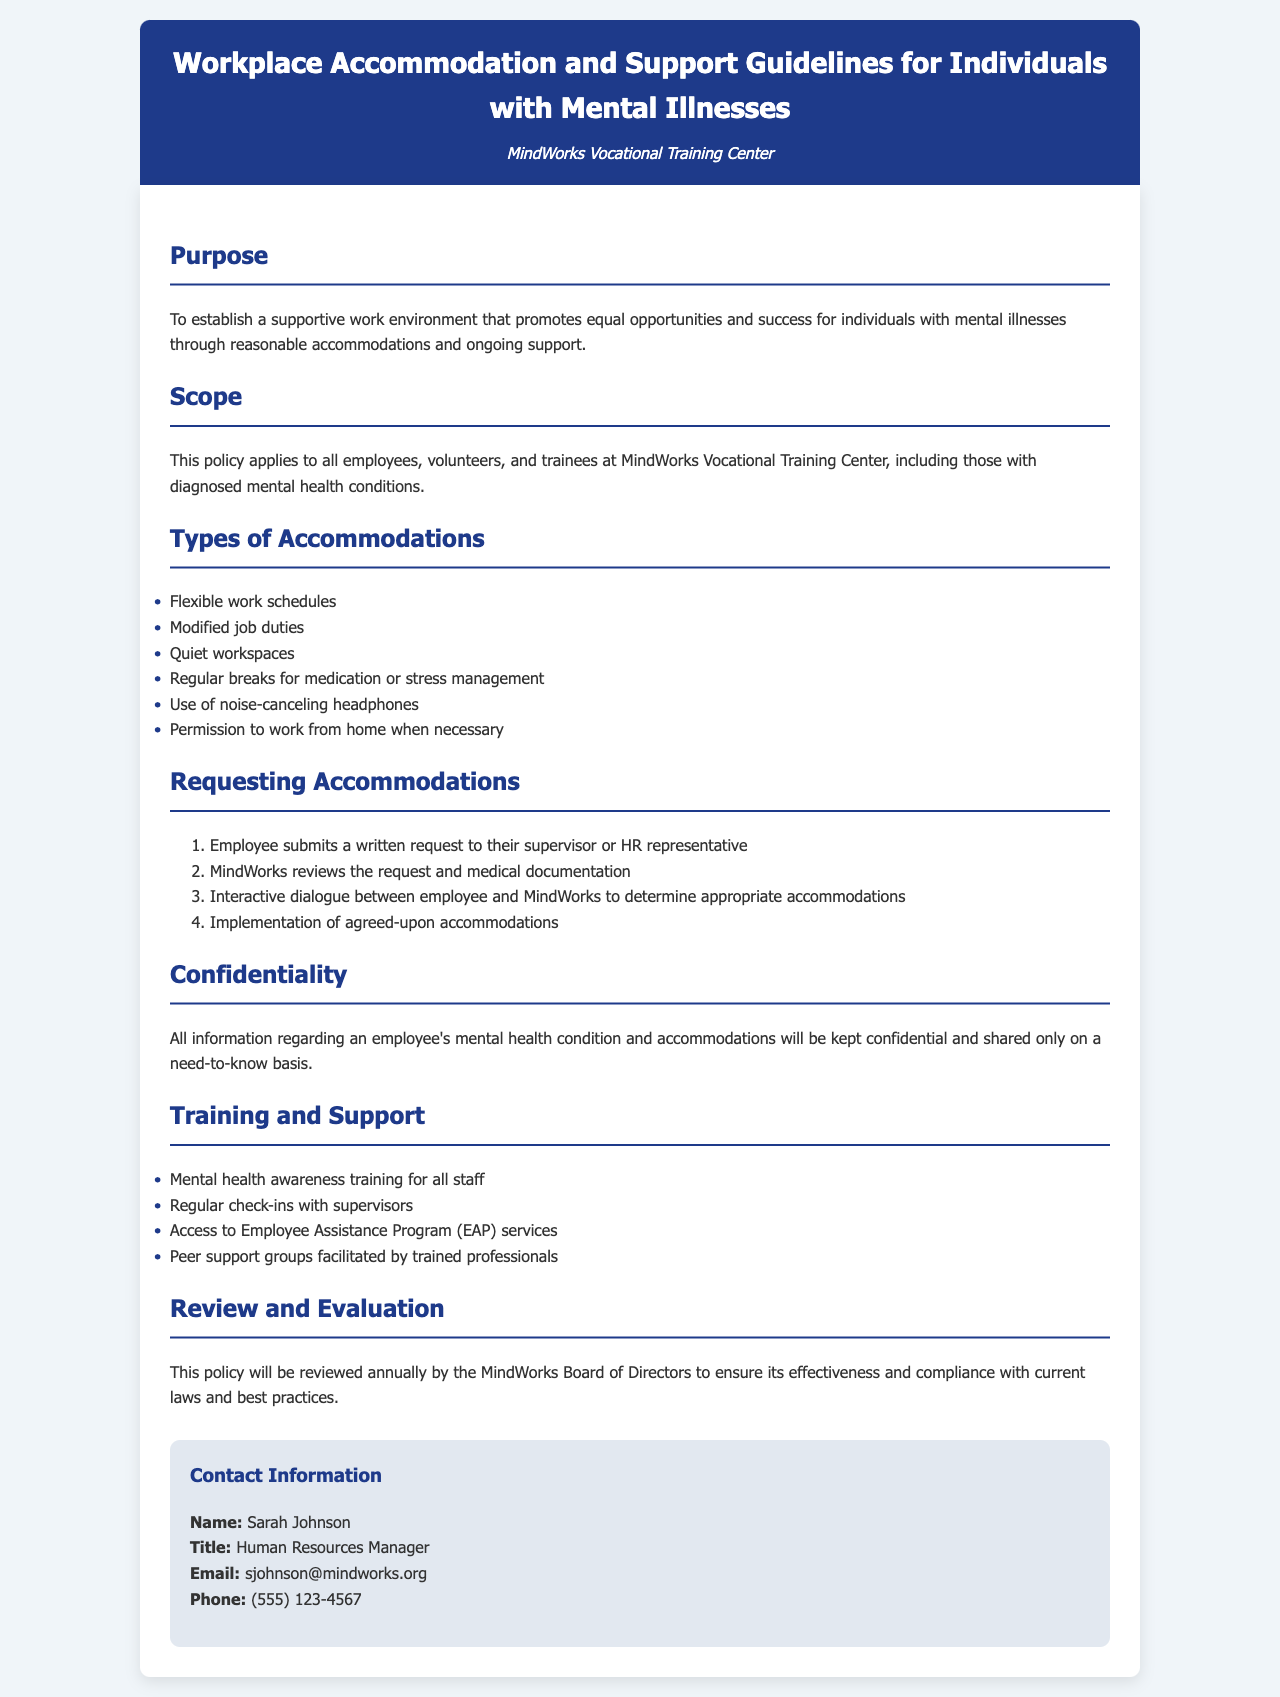What is the purpose of the guidelines? The purpose is to establish a supportive work environment that promotes equal opportunities and success for individuals with mental illnesses.
Answer: To establish a supportive work environment that promotes equal opportunities and success for individuals with mental illnesses Who is the Human Resources Manager? The document specifies the Human Resources Manager's name in the contact information section.
Answer: Sarah Johnson What types of accommodations are listed? The types of accommodations are detailed in a specific section of the document, listing various options.
Answer: Flexible work schedules, Modified job duties, Quiet workspaces, Regular breaks for medication or stress management, Use of noise-canceling headphones, Permission to work from home when necessary How many steps are there in requesting accommodations? The number of steps is detailed in the section that describes the process of requesting accommodations.
Answer: Four steps What will be reviewed annually? The policy mentions that it will be reviewed annually to ensure its effectiveness and compliance.
Answer: This policy What is ensured regarding confidentiality? The document outlines how information regarding an employee's mental health condition and accommodations will be treated.
Answer: Kept confidential and shared only on a need-to-know basis What training is provided to staff? The document lists various forms of training and support available to staff in a specific section.
Answer: Mental health awareness training for all staff What is the email address for the Human Resources Manager? The email address is found in the contact information section and provides a means of communication.
Answer: sjohnson@mindworks.org What is the background color of the main section? The background color of the main section is described in the styling part of the code associated with the document.
Answer: White 